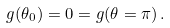<formula> <loc_0><loc_0><loc_500><loc_500>g ( \theta _ { 0 } ) = 0 = g ( \theta = \pi ) \, .</formula> 